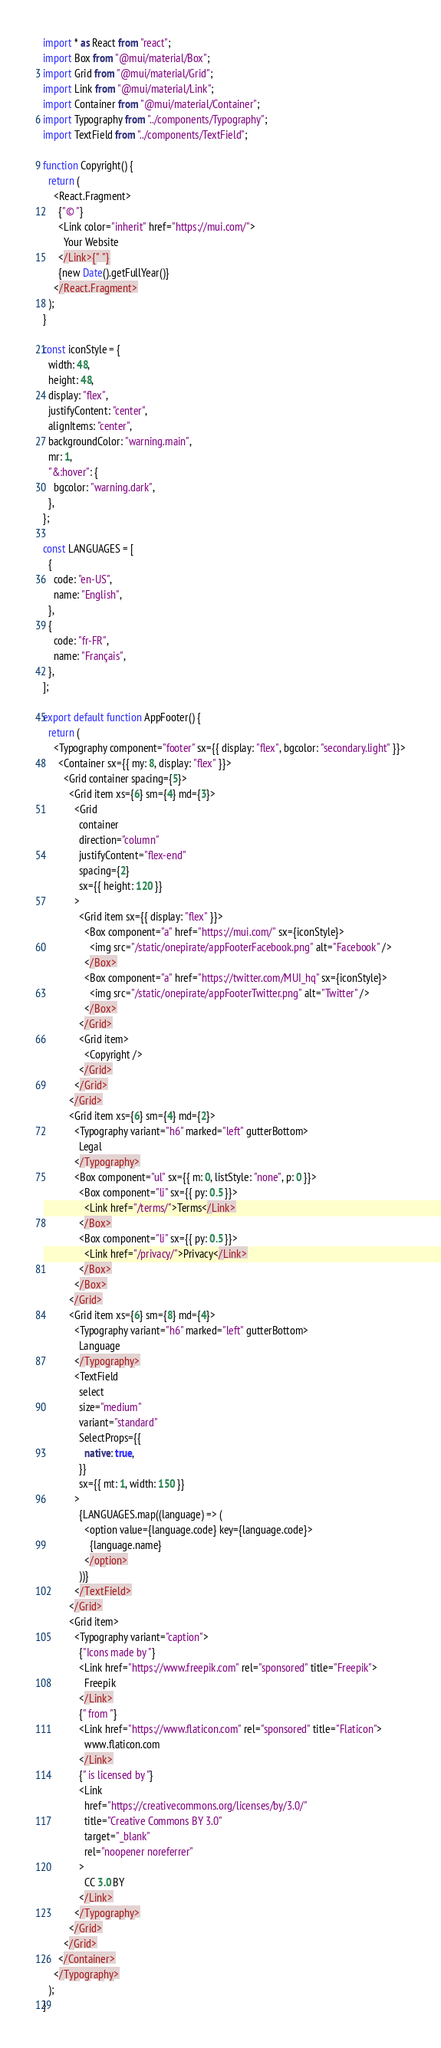Convert code to text. <code><loc_0><loc_0><loc_500><loc_500><_JavaScript_>import * as React from "react";
import Box from "@mui/material/Box";
import Grid from "@mui/material/Grid";
import Link from "@mui/material/Link";
import Container from "@mui/material/Container";
import Typography from "../components/Typography";
import TextField from "../components/TextField";

function Copyright() {
  return (
    <React.Fragment>
      {"© "}
      <Link color="inherit" href="https://mui.com/">
        Your Website
      </Link>{" "}
      {new Date().getFullYear()}
    </React.Fragment>
  );
}

const iconStyle = {
  width: 48,
  height: 48,
  display: "flex",
  justifyContent: "center",
  alignItems: "center",
  backgroundColor: "warning.main",
  mr: 1,
  "&:hover": {
    bgcolor: "warning.dark",
  },
};

const LANGUAGES = [
  {
    code: "en-US",
    name: "English",
  },
  {
    code: "fr-FR",
    name: "Français",
  },
];

export default function AppFooter() {
  return (
    <Typography component="footer" sx={{ display: "flex", bgcolor: "secondary.light" }}>
      <Container sx={{ my: 8, display: "flex" }}>
        <Grid container spacing={5}>
          <Grid item xs={6} sm={4} md={3}>
            <Grid
              container
              direction="column"
              justifyContent="flex-end"
              spacing={2}
              sx={{ height: 120 }}
            >
              <Grid item sx={{ display: "flex" }}>
                <Box component="a" href="https://mui.com/" sx={iconStyle}>
                  <img src="/static/onepirate/appFooterFacebook.png" alt="Facebook" />
                </Box>
                <Box component="a" href="https://twitter.com/MUI_hq" sx={iconStyle}>
                  <img src="/static/onepirate/appFooterTwitter.png" alt="Twitter" />
                </Box>
              </Grid>
              <Grid item>
                <Copyright />
              </Grid>
            </Grid>
          </Grid>
          <Grid item xs={6} sm={4} md={2}>
            <Typography variant="h6" marked="left" gutterBottom>
              Legal
            </Typography>
            <Box component="ul" sx={{ m: 0, listStyle: "none", p: 0 }}>
              <Box component="li" sx={{ py: 0.5 }}>
                <Link href="/terms/">Terms</Link>
              </Box>
              <Box component="li" sx={{ py: 0.5 }}>
                <Link href="/privacy/">Privacy</Link>
              </Box>
            </Box>
          </Grid>
          <Grid item xs={6} sm={8} md={4}>
            <Typography variant="h6" marked="left" gutterBottom>
              Language
            </Typography>
            <TextField
              select
              size="medium"
              variant="standard"
              SelectProps={{
                native: true,
              }}
              sx={{ mt: 1, width: 150 }}
            >
              {LANGUAGES.map((language) => (
                <option value={language.code} key={language.code}>
                  {language.name}
                </option>
              ))}
            </TextField>
          </Grid>
          <Grid item>
            <Typography variant="caption">
              {"Icons made by "}
              <Link href="https://www.freepik.com" rel="sponsored" title="Freepik">
                Freepik
              </Link>
              {" from "}
              <Link href="https://www.flaticon.com" rel="sponsored" title="Flaticon">
                www.flaticon.com
              </Link>
              {" is licensed by "}
              <Link
                href="https://creativecommons.org/licenses/by/3.0/"
                title="Creative Commons BY 3.0"
                target="_blank"
                rel="noopener noreferrer"
              >
                CC 3.0 BY
              </Link>
            </Typography>
          </Grid>
        </Grid>
      </Container>
    </Typography>
  );
}
</code> 